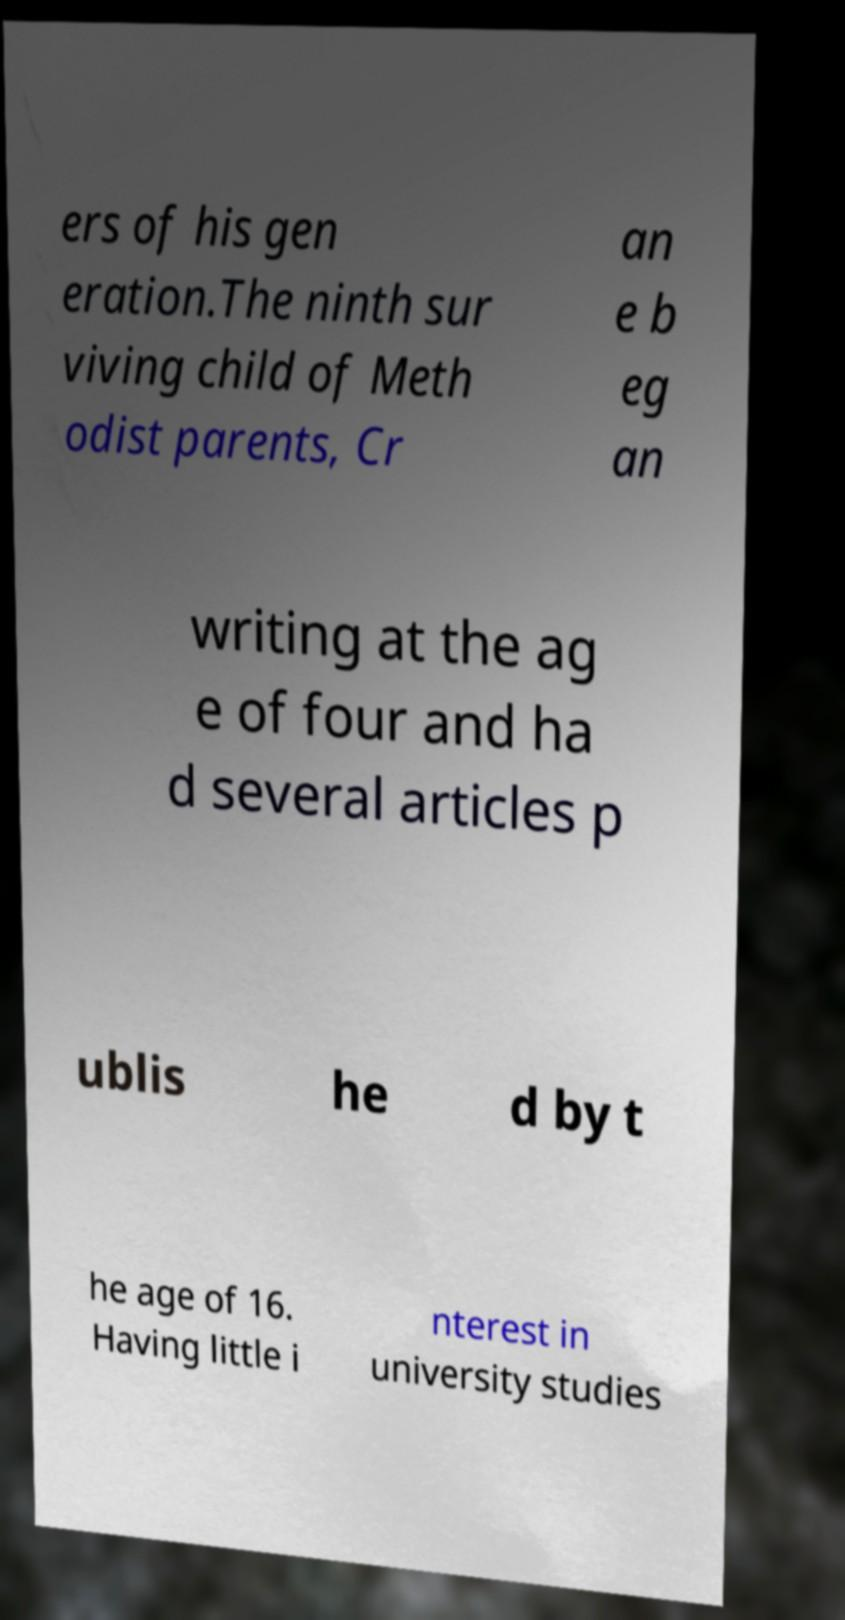Can you accurately transcribe the text from the provided image for me? ers of his gen eration.The ninth sur viving child of Meth odist parents, Cr an e b eg an writing at the ag e of four and ha d several articles p ublis he d by t he age of 16. Having little i nterest in university studies 